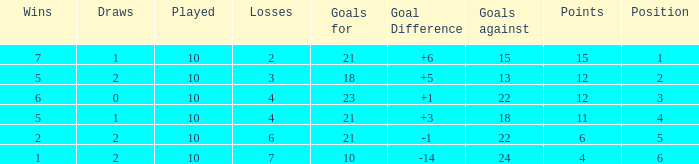Can you tell me the sum of Goals against that has the Goals for larger than 10, and the Position of 3, and the Wins smaller than 6? None. 